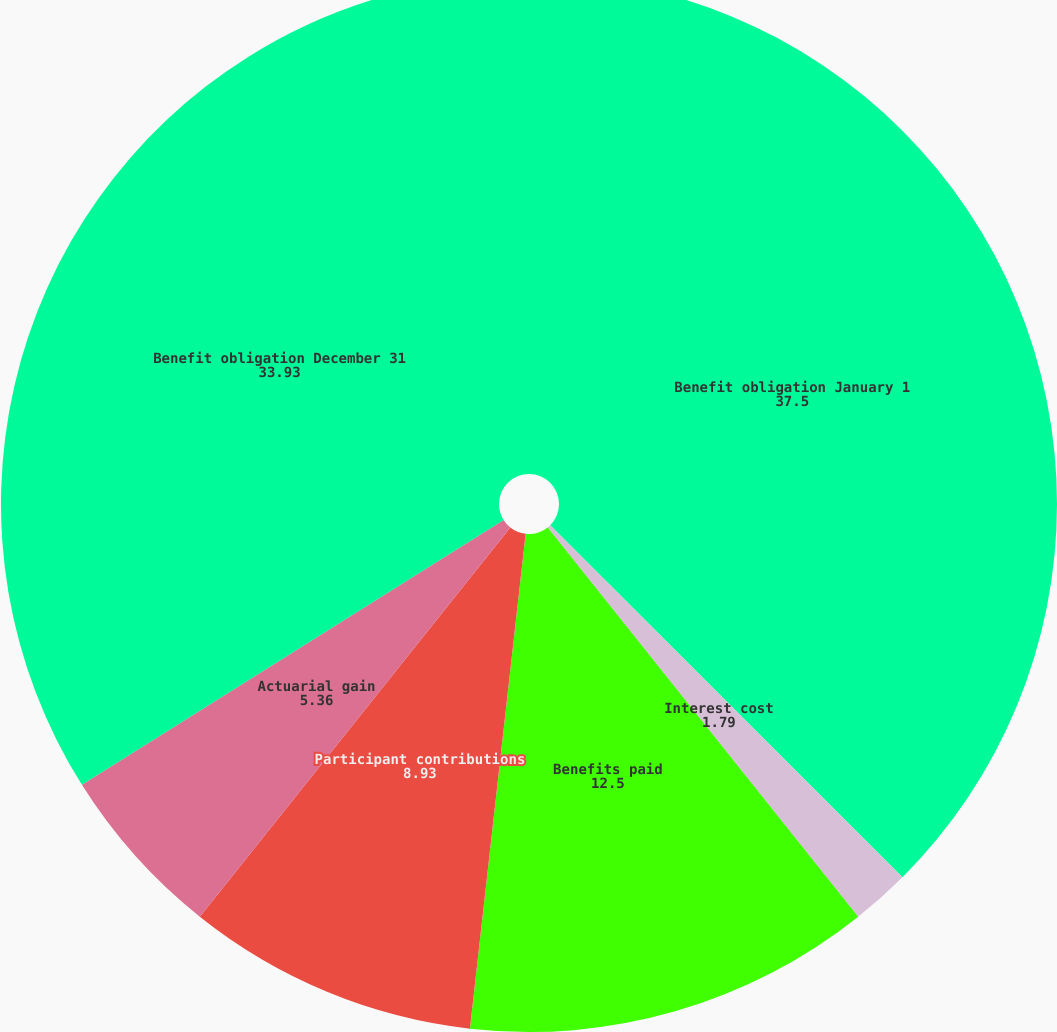Convert chart to OTSL. <chart><loc_0><loc_0><loc_500><loc_500><pie_chart><fcel>Benefit obligation January 1<fcel>Interest cost<fcel>Benefits paid<fcel>Participant contributions<fcel>Actuarial gain<fcel>Benefit obligation December 31<nl><fcel>37.5%<fcel>1.79%<fcel>12.5%<fcel>8.93%<fcel>5.36%<fcel>33.93%<nl></chart> 